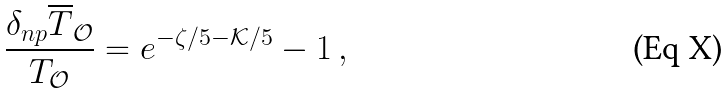<formula> <loc_0><loc_0><loc_500><loc_500>\frac { \delta _ { n p } \overline { T } _ { \mathcal { O } } } { T _ { \mathcal { O } } } = e ^ { - \zeta / 5 - { \mathcal { K } } / 5 } - 1 \, ,</formula> 